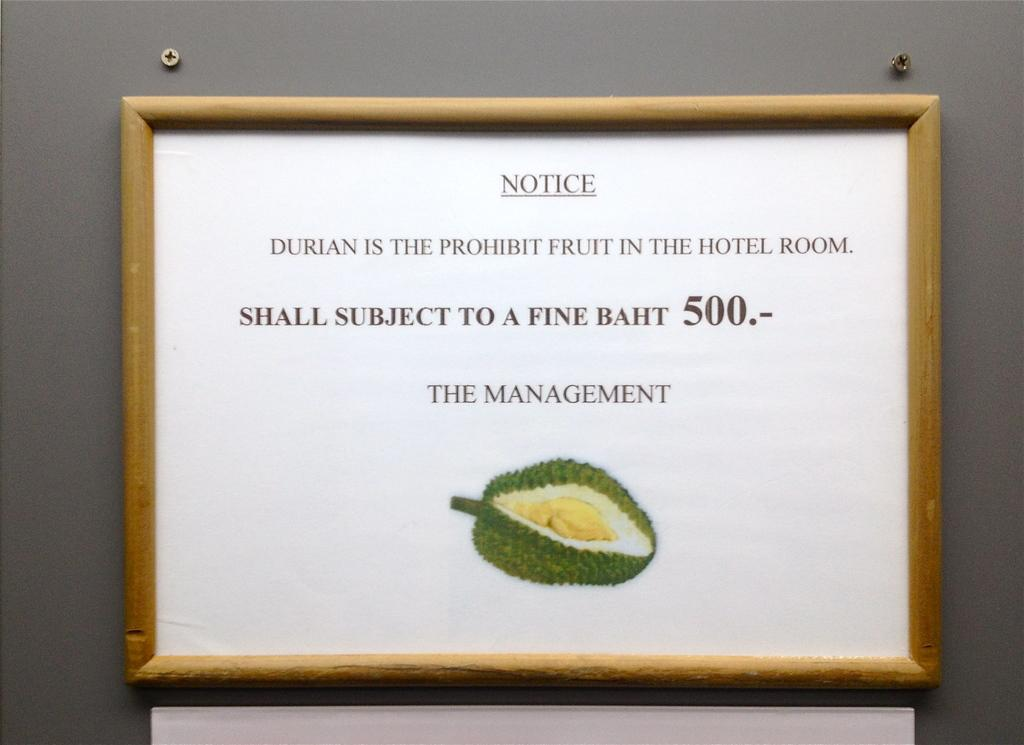<image>
Share a concise interpretation of the image provided. A framed image of a durian says that the durian is prohibited in the hotel room. 